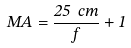Convert formula to latex. <formula><loc_0><loc_0><loc_500><loc_500>M A = { \frac { 2 5 \ c m } { f } } + 1</formula> 